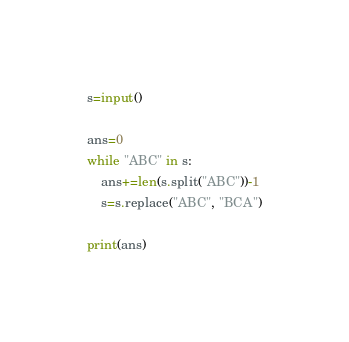Convert code to text. <code><loc_0><loc_0><loc_500><loc_500><_Python_>s=input()

ans=0
while "ABC" in s:
    ans+=len(s.split("ABC"))-1
    s=s.replace("ABC", "BCA")

print(ans)</code> 